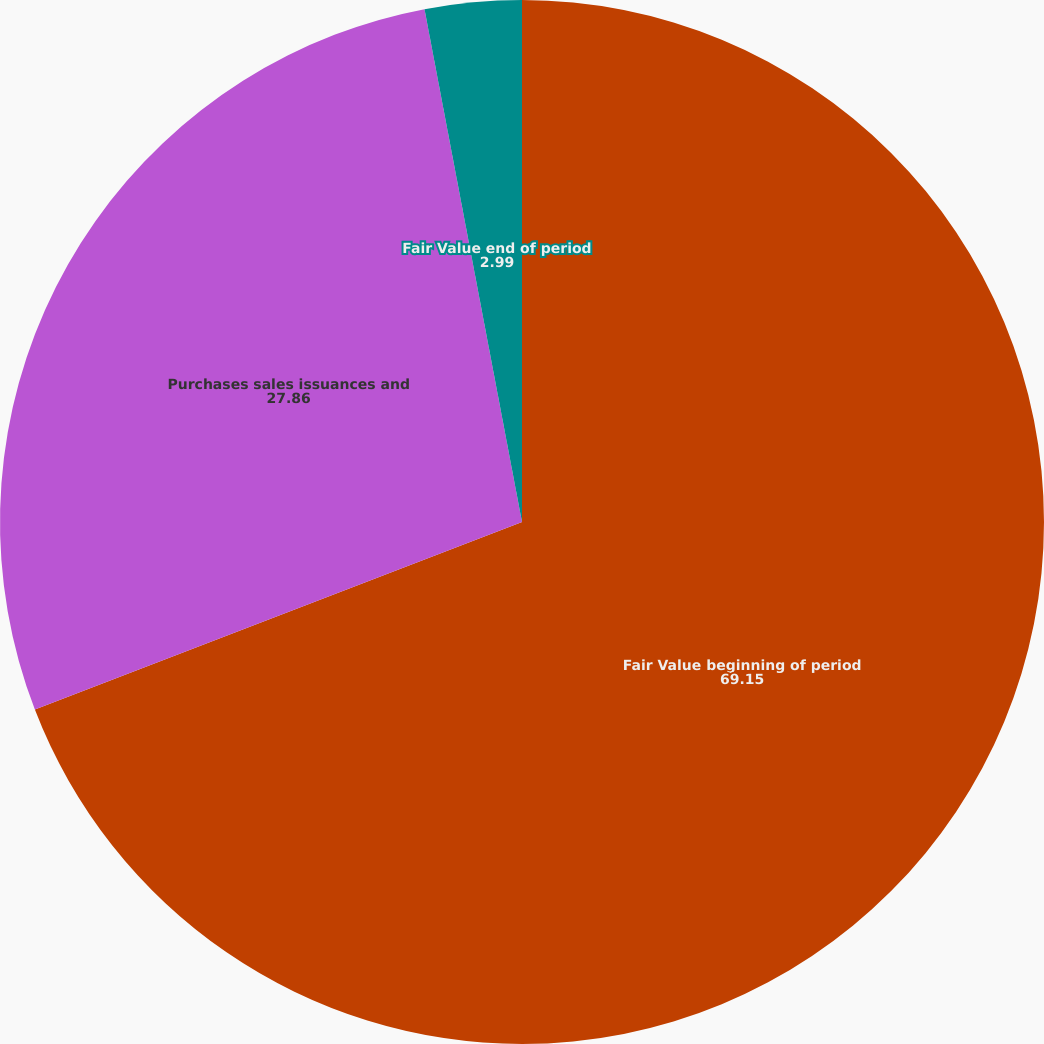Convert chart to OTSL. <chart><loc_0><loc_0><loc_500><loc_500><pie_chart><fcel>Fair Value beginning of period<fcel>Purchases sales issuances and<fcel>Fair Value end of period<nl><fcel>69.15%<fcel>27.86%<fcel>2.99%<nl></chart> 